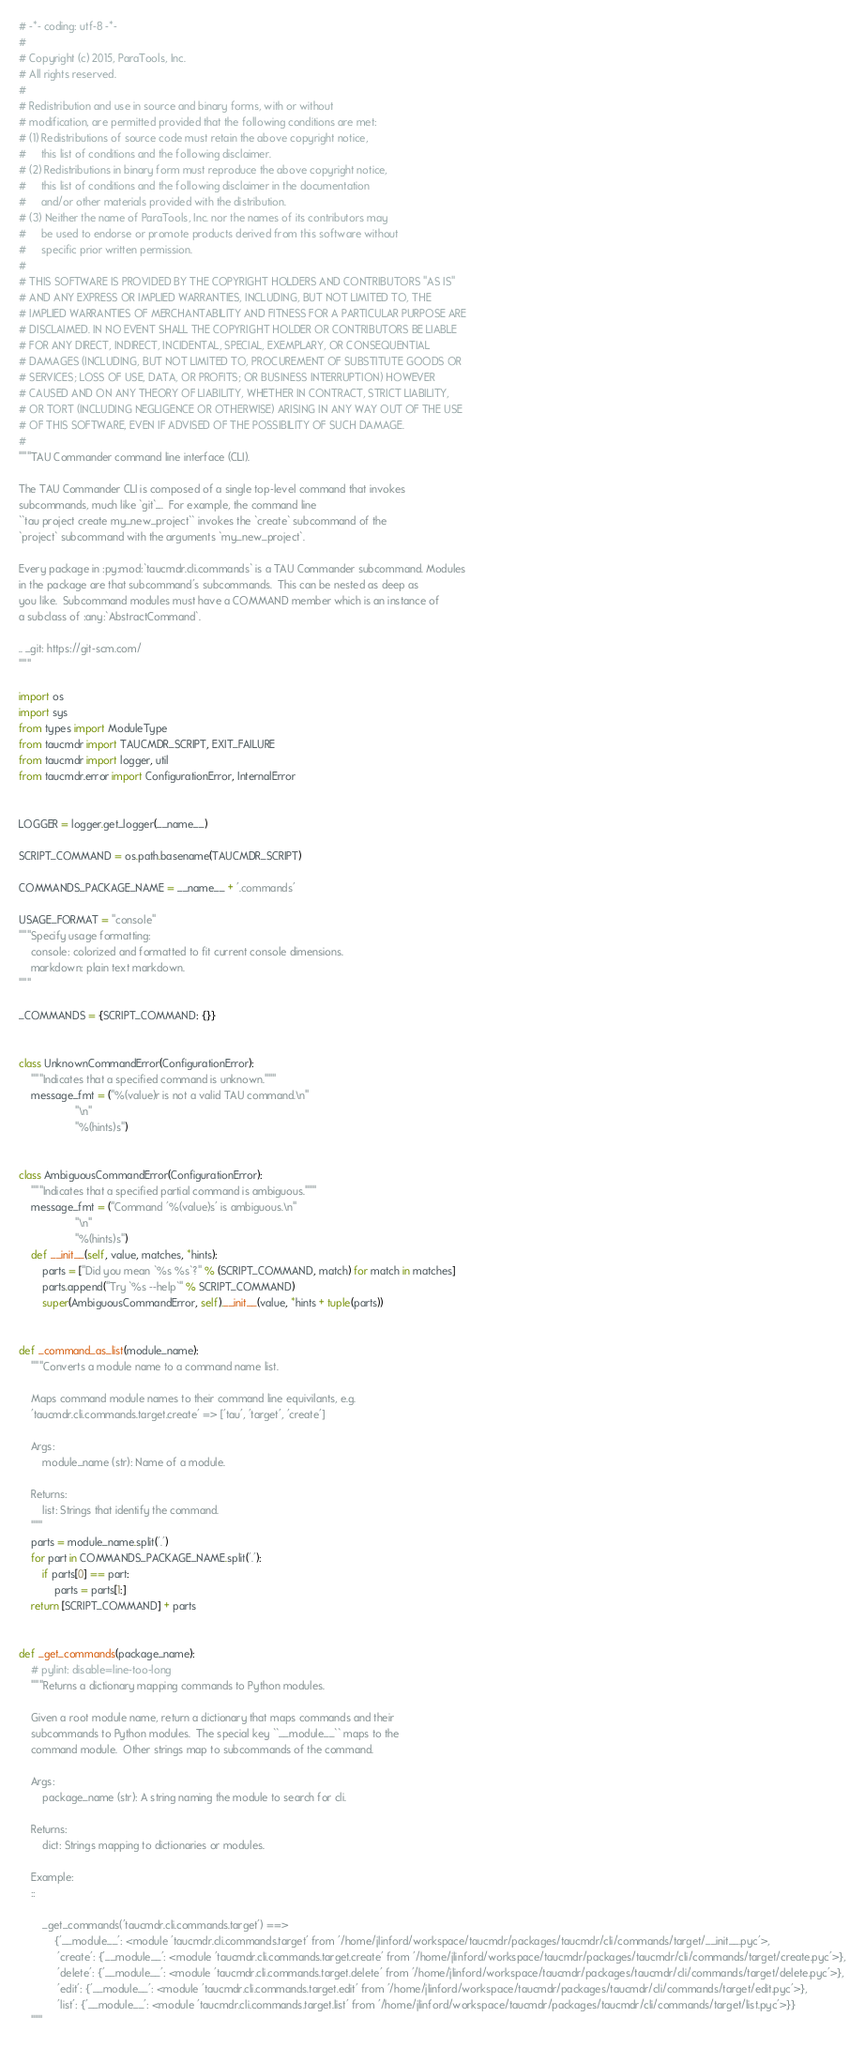<code> <loc_0><loc_0><loc_500><loc_500><_Python_># -*- coding: utf-8 -*-
#
# Copyright (c) 2015, ParaTools, Inc.
# All rights reserved.
#
# Redistribution and use in source and binary forms, with or without
# modification, are permitted provided that the following conditions are met:
# (1) Redistributions of source code must retain the above copyright notice,
#     this list of conditions and the following disclaimer.
# (2) Redistributions in binary form must reproduce the above copyright notice,
#     this list of conditions and the following disclaimer in the documentation
#     and/or other materials provided with the distribution.
# (3) Neither the name of ParaTools, Inc. nor the names of its contributors may
#     be used to endorse or promote products derived from this software without
#     specific prior written permission.
#
# THIS SOFTWARE IS PROVIDED BY THE COPYRIGHT HOLDERS AND CONTRIBUTORS "AS IS"
# AND ANY EXPRESS OR IMPLIED WARRANTIES, INCLUDING, BUT NOT LIMITED TO, THE
# IMPLIED WARRANTIES OF MERCHANTABILITY AND FITNESS FOR A PARTICULAR PURPOSE ARE
# DISCLAIMED. IN NO EVENT SHALL THE COPYRIGHT HOLDER OR CONTRIBUTORS BE LIABLE
# FOR ANY DIRECT, INDIRECT, INCIDENTAL, SPECIAL, EXEMPLARY, OR CONSEQUENTIAL
# DAMAGES (INCLUDING, BUT NOT LIMITED TO, PROCUREMENT OF SUBSTITUTE GOODS OR
# SERVICES; LOSS OF USE, DATA, OR PROFITS; OR BUSINESS INTERRUPTION) HOWEVER
# CAUSED AND ON ANY THEORY OF LIABILITY, WHETHER IN CONTRACT, STRICT LIABILITY,
# OR TORT (INCLUDING NEGLIGENCE OR OTHERWISE) ARISING IN ANY WAY OUT OF THE USE
# OF THIS SOFTWARE, EVEN IF ADVISED OF THE POSSIBILITY OF SUCH DAMAGE.
#
"""TAU Commander command line interface (CLI).

The TAU Commander CLI is composed of a single top-level command that invokes
subcommands, much like `git`_.  For example, the command line 
``tau project create my_new_project`` invokes the `create` subcommand of the
`project` subcommand with the arguments `my_new_project`. 

Every package in :py:mod:`taucmdr.cli.commands` is a TAU Commander subcommand. Modules
in the package are that subcommand's subcommands.  This can be nested as deep as
you like.  Subcommand modules must have a COMMAND member which is an instance of
a subclass of :any:`AbstractCommand`.

.. _git: https://git-scm.com/
"""

import os
import sys
from types import ModuleType
from taucmdr import TAUCMDR_SCRIPT, EXIT_FAILURE
from taucmdr import logger, util
from taucmdr.error import ConfigurationError, InternalError


LOGGER = logger.get_logger(__name__)

SCRIPT_COMMAND = os.path.basename(TAUCMDR_SCRIPT)

COMMANDS_PACKAGE_NAME = __name__ + '.commands'

USAGE_FORMAT = "console"
"""Specify usage formatting:
    console: colorized and formatted to fit current console dimensions.
    markdown: plain text markdown. 
""" 

_COMMANDS = {SCRIPT_COMMAND: {}}


class UnknownCommandError(ConfigurationError):
    """Indicates that a specified command is unknown."""
    message_fmt = ("%(value)r is not a valid TAU command.\n"
                   "\n"
                   "%(hints)s")


class AmbiguousCommandError(ConfigurationError):
    """Indicates that a specified partial command is ambiguous."""
    message_fmt = ("Command '%(value)s' is ambiguous.\n"
                   "\n"
                   "%(hints)s")
    def __init__(self, value, matches, *hints):
        parts = ["Did you mean `%s %s`?" % (SCRIPT_COMMAND, match) for match in matches]
        parts.append("Try `%s --help`" % SCRIPT_COMMAND)
        super(AmbiguousCommandError, self).__init__(value, *hints + tuple(parts))


def _command_as_list(module_name):
    """Converts a module name to a command name list.
    
    Maps command module names to their command line equivilants, e.g.
    'taucmdr.cli.commands.target.create' => ['tau', 'target', 'create']

    Args:
        module_name (str): Name of a module.

    Returns:
        list: Strings that identify the command.
    """
    parts = module_name.split('.')
    for part in COMMANDS_PACKAGE_NAME.split('.'):
        if parts[0] == part:
            parts = parts[1:]
    return [SCRIPT_COMMAND] + parts


def _get_commands(package_name):
    # pylint: disable=line-too-long
    """Returns a dictionary mapping commands to Python modules.
    
    Given a root module name, return a dictionary that maps commands and their
    subcommands to Python modules.  The special key ``__module__`` maps to the
    command module.  Other strings map to subcommands of the command.
    
    Args:
        package_name (str): A string naming the module to search for cli.
    
    Returns:
        dict: Strings mapping to dictionaries or modules.
        
    Example:
    ::

        _get_commands('taucmdr.cli.commands.target') ==>
            {'__module__': <module 'taucmdr.cli.commands.target' from '/home/jlinford/workspace/taucmdr/packages/taucmdr/cli/commands/target/__init__.pyc'>,
             'create': {'__module__': <module 'taucmdr.cli.commands.target.create' from '/home/jlinford/workspace/taucmdr/packages/taucmdr/cli/commands/target/create.pyc'>},
             'delete': {'__module__': <module 'taucmdr.cli.commands.target.delete' from '/home/jlinford/workspace/taucmdr/packages/taucmdr/cli/commands/target/delete.pyc'>},
             'edit': {'__module__': <module 'taucmdr.cli.commands.target.edit' from '/home/jlinford/workspace/taucmdr/packages/taucmdr/cli/commands/target/edit.pyc'>},
             'list': {'__module__': <module 'taucmdr.cli.commands.target.list' from '/home/jlinford/workspace/taucmdr/packages/taucmdr/cli/commands/target/list.pyc'>}}
    """</code> 